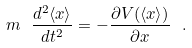Convert formula to latex. <formula><loc_0><loc_0><loc_500><loc_500>m \ \frac { d ^ { 2 } \langle x \rangle } { d t ^ { 2 } } = - \frac { \partial V ( \langle x \rangle ) } { \partial x } \ .</formula> 